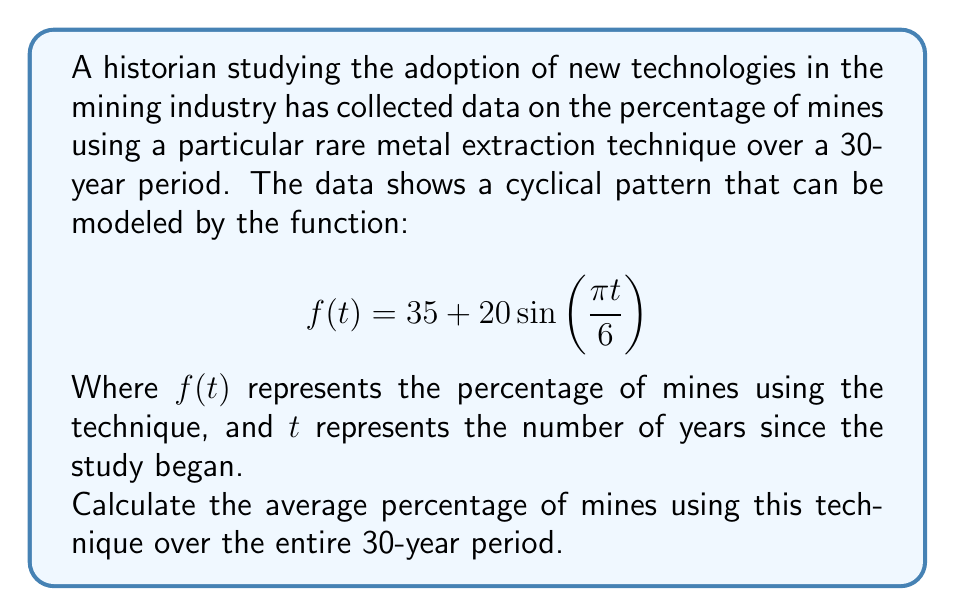Give your solution to this math problem. To solve this problem, we need to calculate the average value of the function over the given time interval. This can be done using the definite integral:

1) The average value of a function $f(t)$ over an interval $[a,b]$ is given by:

   $$ \text{Average} = \frac{1}{b-a} \int_{a}^{b} f(t) dt $$

2) In our case, $a=0$, $b=30$, and $f(t) = 35 + 20\sin(\frac{\pi t}{6})$. So we need to calculate:

   $$ \text{Average} = \frac{1}{30} \int_{0}^{30} (35 + 20\sin(\frac{\pi t}{6})) dt $$

3) Let's solve the integral:

   $$ \int_{0}^{30} (35 + 20\sin(\frac{\pi t}{6})) dt = [35t - \frac{120}{\pi}\cos(\frac{\pi t}{6})]_{0}^{30} $$

4) Evaluating at the bounds:

   $$ = (35 \cdot 30 - \frac{120}{\pi}\cos(5\pi)) - (0 - \frac{120}{\pi}\cos(0)) $$

5) Simplify:

   $$ = 1050 - \frac{120}{\pi}(\cos(5\pi) - 1) $$

6) Note that $\cos(5\pi) = \cos(\pi) = -1$, so:

   $$ = 1050 - \frac{120}{\pi}(-1 - 1) = 1050 + \frac{240}{\pi} $$

7) Now, divide by 30 to get the average:

   $$ \text{Average} = \frac{1}{30}(1050 + \frac{240}{\pi}) = 35 + \frac{8}{\pi} $$

8) This evaluates to approximately 37.55%.
Answer: The average percentage of mines using the technique over the 30-year period is $35 + \frac{8}{\pi}$%, or approximately 37.55%. 